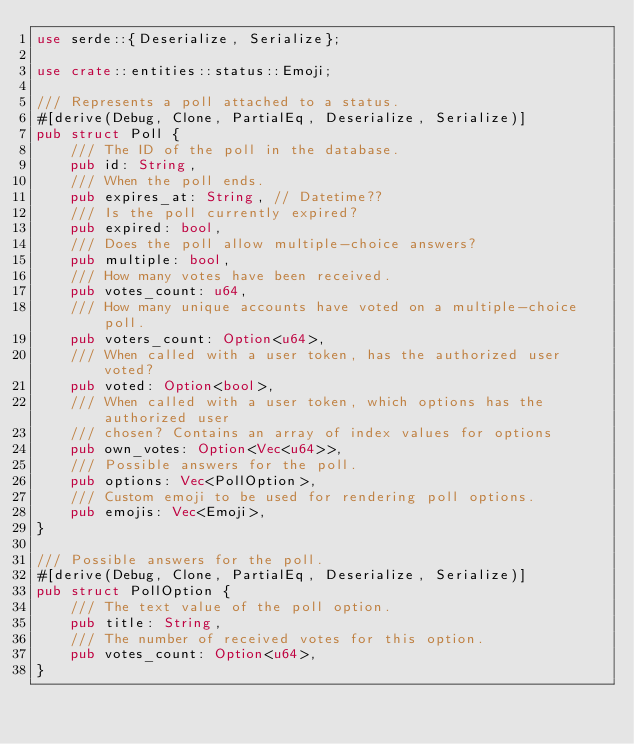Convert code to text. <code><loc_0><loc_0><loc_500><loc_500><_Rust_>use serde::{Deserialize, Serialize};

use crate::entities::status::Emoji;

/// Represents a poll attached to a status.
#[derive(Debug, Clone, PartialEq, Deserialize, Serialize)]
pub struct Poll {
	/// The ID of the poll in the database.
	pub id: String,
	/// When the poll ends.
	pub expires_at: String, // Datetime??
	/// Is the poll currently expired?
	pub expired: bool,
	/// Does the poll allow multiple-choice answers?
	pub multiple: bool,
	/// How many votes have been received.
	pub votes_count: u64,
	/// How many unique accounts have voted on a multiple-choice poll.
	pub voters_count: Option<u64>,
	/// When called with a user token, has the authorized user voted?
	pub voted: Option<bool>,
	/// When called with a user token, which options has the authorized user
	/// chosen? Contains an array of index values for options
	pub own_votes: Option<Vec<u64>>,
	/// Possible answers for the poll.
	pub options: Vec<PollOption>,
	/// Custom emoji to be used for rendering poll options.
	pub emojis: Vec<Emoji>,
}

/// Possible answers for the poll.
#[derive(Debug, Clone, PartialEq, Deserialize, Serialize)]
pub struct PollOption {
	/// The text value of the poll option.
	pub title: String,
	/// The number of received votes for this option.
	pub votes_count: Option<u64>,
}
</code> 